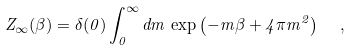<formula> <loc_0><loc_0><loc_500><loc_500>Z _ { \infty } ( \beta ) = \delta ( 0 ) \int _ { 0 } ^ { \infty } d { m } \, \exp \left ( - { m } \beta + 4 \pi { m } ^ { 2 } \right ) \ \ ,</formula> 